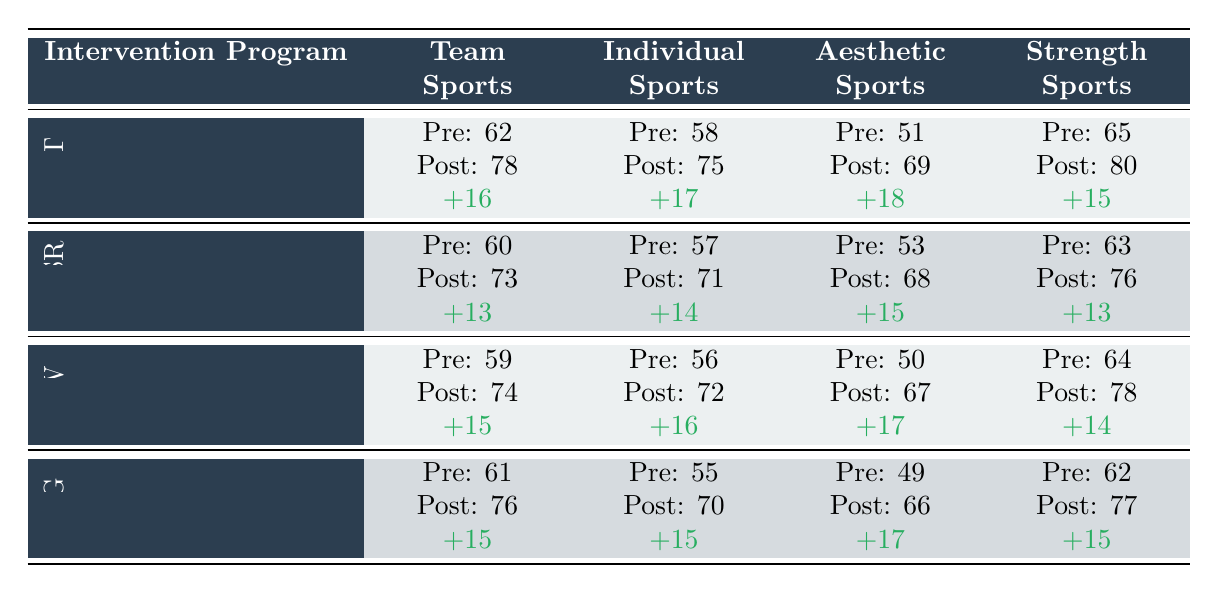What is the pre-intervention score for Team Sports under the 'Cognitive Behavioral Therapy' program? The table lists the pre-intervention score for Team Sports under 'Cognitive Behavioral Therapy' as 62.
Answer: 62 What was the change in body image perception for Aesthetic Sports in the Intuitive Eating Workshop? The change in body image perception for Aesthetic Sports in the Intuitive Eating Workshop is calculated as the post-intervention score (67) minus the pre-intervention score (50), which equals 17.
Answer: 17 Which intervention program had the highest post-intervention score for Individual Sports? By comparing the post-intervention scores for Individual Sports across all programs, 'Cognitive Behavioral Therapy' has the highest post score of 75.
Answer: 75 What is the average change in body image perception scores across all sports for the Body Appreciation Group? The changes for Body Appreciation Group across all sports are +15, +15, +17, and +15. The sum is 62, and there are 4 scores, so the average change is 62/4 = 15.5.
Answer: 15.5 True or False: The post-intervention score for Aesthetic Sports in the Mindfulness-Based Stress Reduction program is higher than 70. The post-intervention score for Aesthetic Sports in the Mindfulness-Based Stress Reduction program is 68, which is not higher than 70.
Answer: False Which intervention program resulted in the largest overall average change across all sports? The average changes for each program are calculated as follows: CBT: (16+17+18+15)/4 = 16.5, MBSR: (13+14+15+13)/4 = 13.75, IEW: (15+16+17+14)/4 = 15.5, BAG: (15+15+17+15)/4 = 15.5. Cognitive Behavioral Therapy has the highest average change of 16.5.
Answer: Cognitive Behavioral Therapy What is the change in body image perception for Team Sports in the Mindfulness-Based Stress Reduction program? The change for Team Sports in the Mindfulness-Based Stress Reduction program is calculated as the post-intervention score (73) minus the pre-intervention score (60), which equals 13.
Answer: 13 Did the Intuitive Eating Workshop program yield a higher pre-intervention score for Individual Sports than the Mindfulness-Based Stress Reduction program? The pre-intervention score for Individual Sports in the Intuitive Eating Workshop is 56, and in the Mindfulness-Based Stress Reduction program, it is 57. Since 56 is lower than 57, the statement is false.
Answer: False Which sport category saw the most significant improvement under the Cognitive Behavioral Therapy intervention? By comparing the changes for each sports category under Cognitive Behavioral Therapy: Team Sports (+16), Individual Sports (+17), Aesthetic Sports (+18), and Strength Sports (+15), Aesthetic Sports saw the most significant improvement with a change of +18.
Answer: Aesthetic Sports 